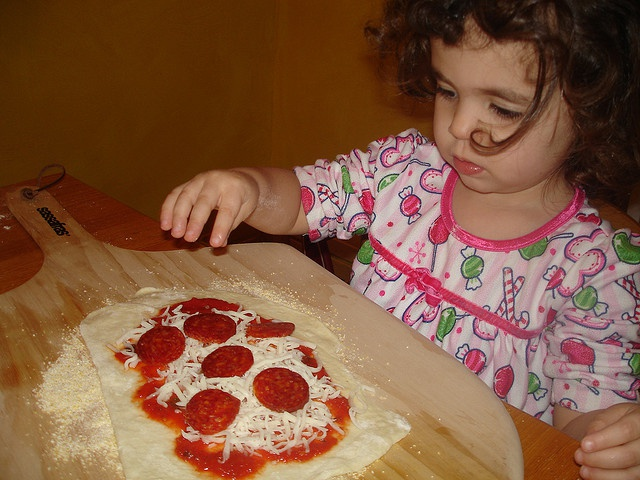Describe the objects in this image and their specific colors. I can see people in black, brown, darkgray, and pink tones, pizza in black, tan, and brown tones, and dining table in black and maroon tones in this image. 